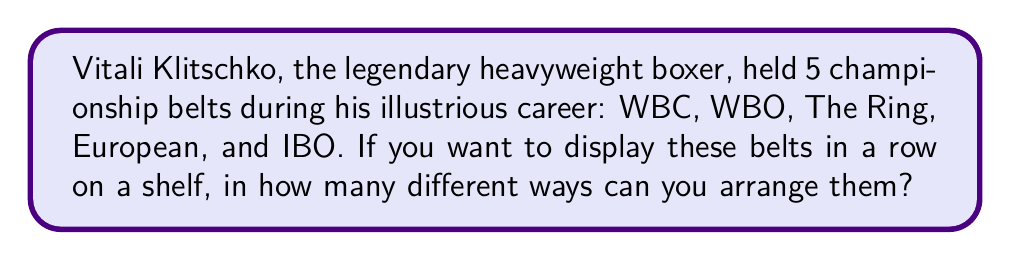Can you answer this question? To solve this problem, we need to use the concept of permutations in combinatorics. 

1) We have 5 distinct championship belts to arrange.

2) Since each belt is unique and we're arranging all of them, this is a straightforward permutation problem.

3) The number of permutations of $n$ distinct objects is given by the factorial of $n$, denoted as $n!$.

4) In this case, $n = 5$ (for the 5 belts).

5) Therefore, the number of ways to arrange the belts is:

   $5! = 5 \times 4 \times 3 \times 2 \times 1 = 120$

Thus, there are 120 different ways to arrange Vitali Klitschko's 5 championship belts on a shelf.
Answer: $120$ 